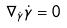Convert formula to latex. <formula><loc_0><loc_0><loc_500><loc_500>\nabla _ { \dot { \gamma } } \dot { \gamma } = 0</formula> 